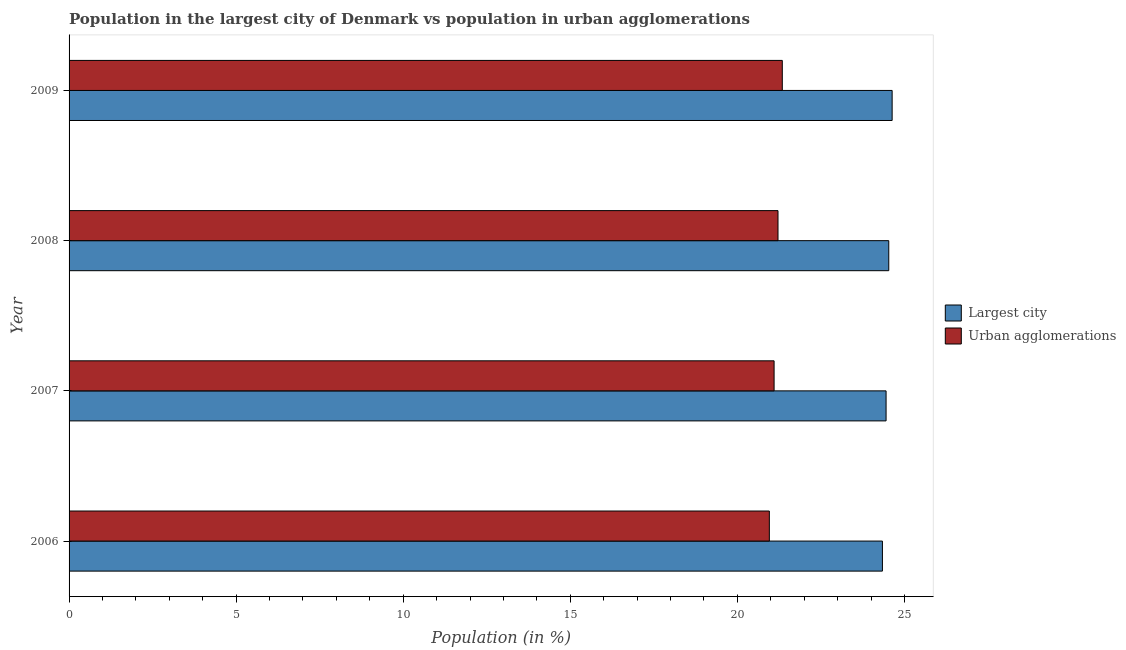How many different coloured bars are there?
Keep it short and to the point. 2. How many bars are there on the 4th tick from the top?
Keep it short and to the point. 2. What is the label of the 2nd group of bars from the top?
Offer a very short reply. 2008. What is the population in the largest city in 2009?
Your answer should be very brief. 24.63. Across all years, what is the maximum population in the largest city?
Keep it short and to the point. 24.63. Across all years, what is the minimum population in urban agglomerations?
Your answer should be compact. 20.96. In which year was the population in urban agglomerations maximum?
Provide a short and direct response. 2009. In which year was the population in the largest city minimum?
Keep it short and to the point. 2006. What is the total population in the largest city in the graph?
Provide a short and direct response. 97.95. What is the difference between the population in the largest city in 2006 and that in 2007?
Your answer should be very brief. -0.11. What is the difference between the population in the largest city in 2006 and the population in urban agglomerations in 2009?
Your answer should be very brief. 3. What is the average population in urban agglomerations per year?
Provide a short and direct response. 21.15. In the year 2007, what is the difference between the population in the largest city and population in urban agglomerations?
Make the answer very short. 3.35. In how many years, is the population in the largest city greater than 24 %?
Give a very brief answer. 4. Is the difference between the population in urban agglomerations in 2007 and 2009 greater than the difference between the population in the largest city in 2007 and 2009?
Provide a short and direct response. No. What is the difference between the highest and the second highest population in urban agglomerations?
Ensure brevity in your answer.  0.13. What is the difference between the highest and the lowest population in the largest city?
Offer a terse response. 0.29. What does the 1st bar from the top in 2008 represents?
Your answer should be very brief. Urban agglomerations. What does the 1st bar from the bottom in 2009 represents?
Your answer should be very brief. Largest city. How many bars are there?
Offer a terse response. 8. What is the difference between two consecutive major ticks on the X-axis?
Provide a succinct answer. 5. Are the values on the major ticks of X-axis written in scientific E-notation?
Offer a very short reply. No. Does the graph contain grids?
Provide a short and direct response. No. Where does the legend appear in the graph?
Keep it short and to the point. Center right. What is the title of the graph?
Ensure brevity in your answer.  Population in the largest city of Denmark vs population in urban agglomerations. What is the Population (in %) in Largest city in 2006?
Make the answer very short. 24.34. What is the Population (in %) in Urban agglomerations in 2006?
Keep it short and to the point. 20.96. What is the Population (in %) of Largest city in 2007?
Provide a succinct answer. 24.45. What is the Population (in %) of Urban agglomerations in 2007?
Ensure brevity in your answer.  21.1. What is the Population (in %) in Largest city in 2008?
Offer a terse response. 24.53. What is the Population (in %) in Urban agglomerations in 2008?
Offer a very short reply. 21.22. What is the Population (in %) in Largest city in 2009?
Your response must be concise. 24.63. What is the Population (in %) in Urban agglomerations in 2009?
Your response must be concise. 21.34. Across all years, what is the maximum Population (in %) in Largest city?
Ensure brevity in your answer.  24.63. Across all years, what is the maximum Population (in %) of Urban agglomerations?
Your response must be concise. 21.34. Across all years, what is the minimum Population (in %) of Largest city?
Give a very brief answer. 24.34. Across all years, what is the minimum Population (in %) of Urban agglomerations?
Your answer should be very brief. 20.96. What is the total Population (in %) in Largest city in the graph?
Your response must be concise. 97.95. What is the total Population (in %) in Urban agglomerations in the graph?
Offer a very short reply. 84.62. What is the difference between the Population (in %) of Largest city in 2006 and that in 2007?
Give a very brief answer. -0.11. What is the difference between the Population (in %) in Urban agglomerations in 2006 and that in 2007?
Give a very brief answer. -0.14. What is the difference between the Population (in %) in Largest city in 2006 and that in 2008?
Keep it short and to the point. -0.19. What is the difference between the Population (in %) in Urban agglomerations in 2006 and that in 2008?
Provide a succinct answer. -0.26. What is the difference between the Population (in %) in Largest city in 2006 and that in 2009?
Ensure brevity in your answer.  -0.29. What is the difference between the Population (in %) of Urban agglomerations in 2006 and that in 2009?
Offer a terse response. -0.39. What is the difference between the Population (in %) in Largest city in 2007 and that in 2008?
Your answer should be compact. -0.08. What is the difference between the Population (in %) in Urban agglomerations in 2007 and that in 2008?
Give a very brief answer. -0.12. What is the difference between the Population (in %) of Largest city in 2007 and that in 2009?
Offer a terse response. -0.18. What is the difference between the Population (in %) of Urban agglomerations in 2007 and that in 2009?
Provide a short and direct response. -0.25. What is the difference between the Population (in %) of Largest city in 2008 and that in 2009?
Your response must be concise. -0.1. What is the difference between the Population (in %) in Urban agglomerations in 2008 and that in 2009?
Offer a terse response. -0.13. What is the difference between the Population (in %) of Largest city in 2006 and the Population (in %) of Urban agglomerations in 2007?
Your response must be concise. 3.24. What is the difference between the Population (in %) of Largest city in 2006 and the Population (in %) of Urban agglomerations in 2008?
Give a very brief answer. 3.12. What is the difference between the Population (in %) of Largest city in 2006 and the Population (in %) of Urban agglomerations in 2009?
Your response must be concise. 3. What is the difference between the Population (in %) of Largest city in 2007 and the Population (in %) of Urban agglomerations in 2008?
Provide a short and direct response. 3.23. What is the difference between the Population (in %) in Largest city in 2007 and the Population (in %) in Urban agglomerations in 2009?
Offer a terse response. 3.11. What is the difference between the Population (in %) of Largest city in 2008 and the Population (in %) of Urban agglomerations in 2009?
Your response must be concise. 3.19. What is the average Population (in %) of Largest city per year?
Your answer should be very brief. 24.49. What is the average Population (in %) in Urban agglomerations per year?
Your answer should be very brief. 21.15. In the year 2006, what is the difference between the Population (in %) of Largest city and Population (in %) of Urban agglomerations?
Offer a very short reply. 3.38. In the year 2007, what is the difference between the Population (in %) of Largest city and Population (in %) of Urban agglomerations?
Ensure brevity in your answer.  3.35. In the year 2008, what is the difference between the Population (in %) of Largest city and Population (in %) of Urban agglomerations?
Your response must be concise. 3.31. In the year 2009, what is the difference between the Population (in %) in Largest city and Population (in %) in Urban agglomerations?
Offer a terse response. 3.29. What is the ratio of the Population (in %) of Urban agglomerations in 2006 to that in 2008?
Your response must be concise. 0.99. What is the ratio of the Population (in %) of Urban agglomerations in 2006 to that in 2009?
Your response must be concise. 0.98. What is the ratio of the Population (in %) of Urban agglomerations in 2007 to that in 2008?
Provide a succinct answer. 0.99. What is the ratio of the Population (in %) in Largest city in 2008 to that in 2009?
Keep it short and to the point. 1. What is the ratio of the Population (in %) of Urban agglomerations in 2008 to that in 2009?
Give a very brief answer. 0.99. What is the difference between the highest and the second highest Population (in %) in Largest city?
Your answer should be compact. 0.1. What is the difference between the highest and the second highest Population (in %) of Urban agglomerations?
Your response must be concise. 0.13. What is the difference between the highest and the lowest Population (in %) of Largest city?
Give a very brief answer. 0.29. What is the difference between the highest and the lowest Population (in %) of Urban agglomerations?
Offer a terse response. 0.39. 